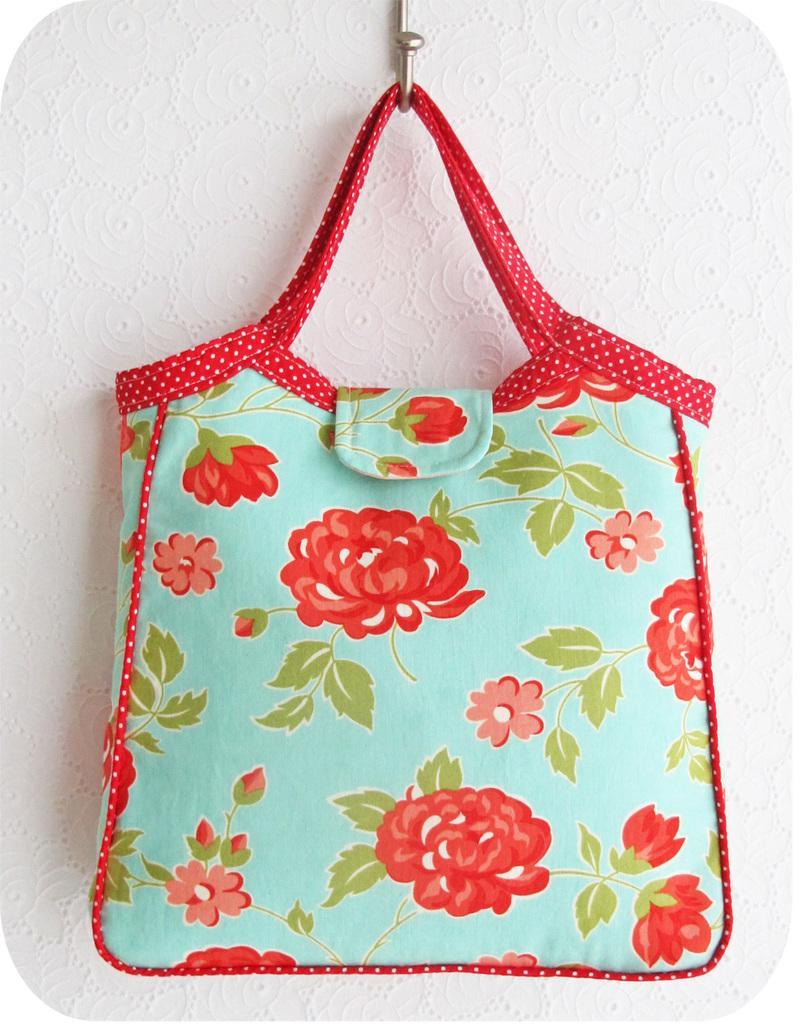Can you describe this image briefly? In the picture there is image of red and blue color bag which is hang to to a hanger. 